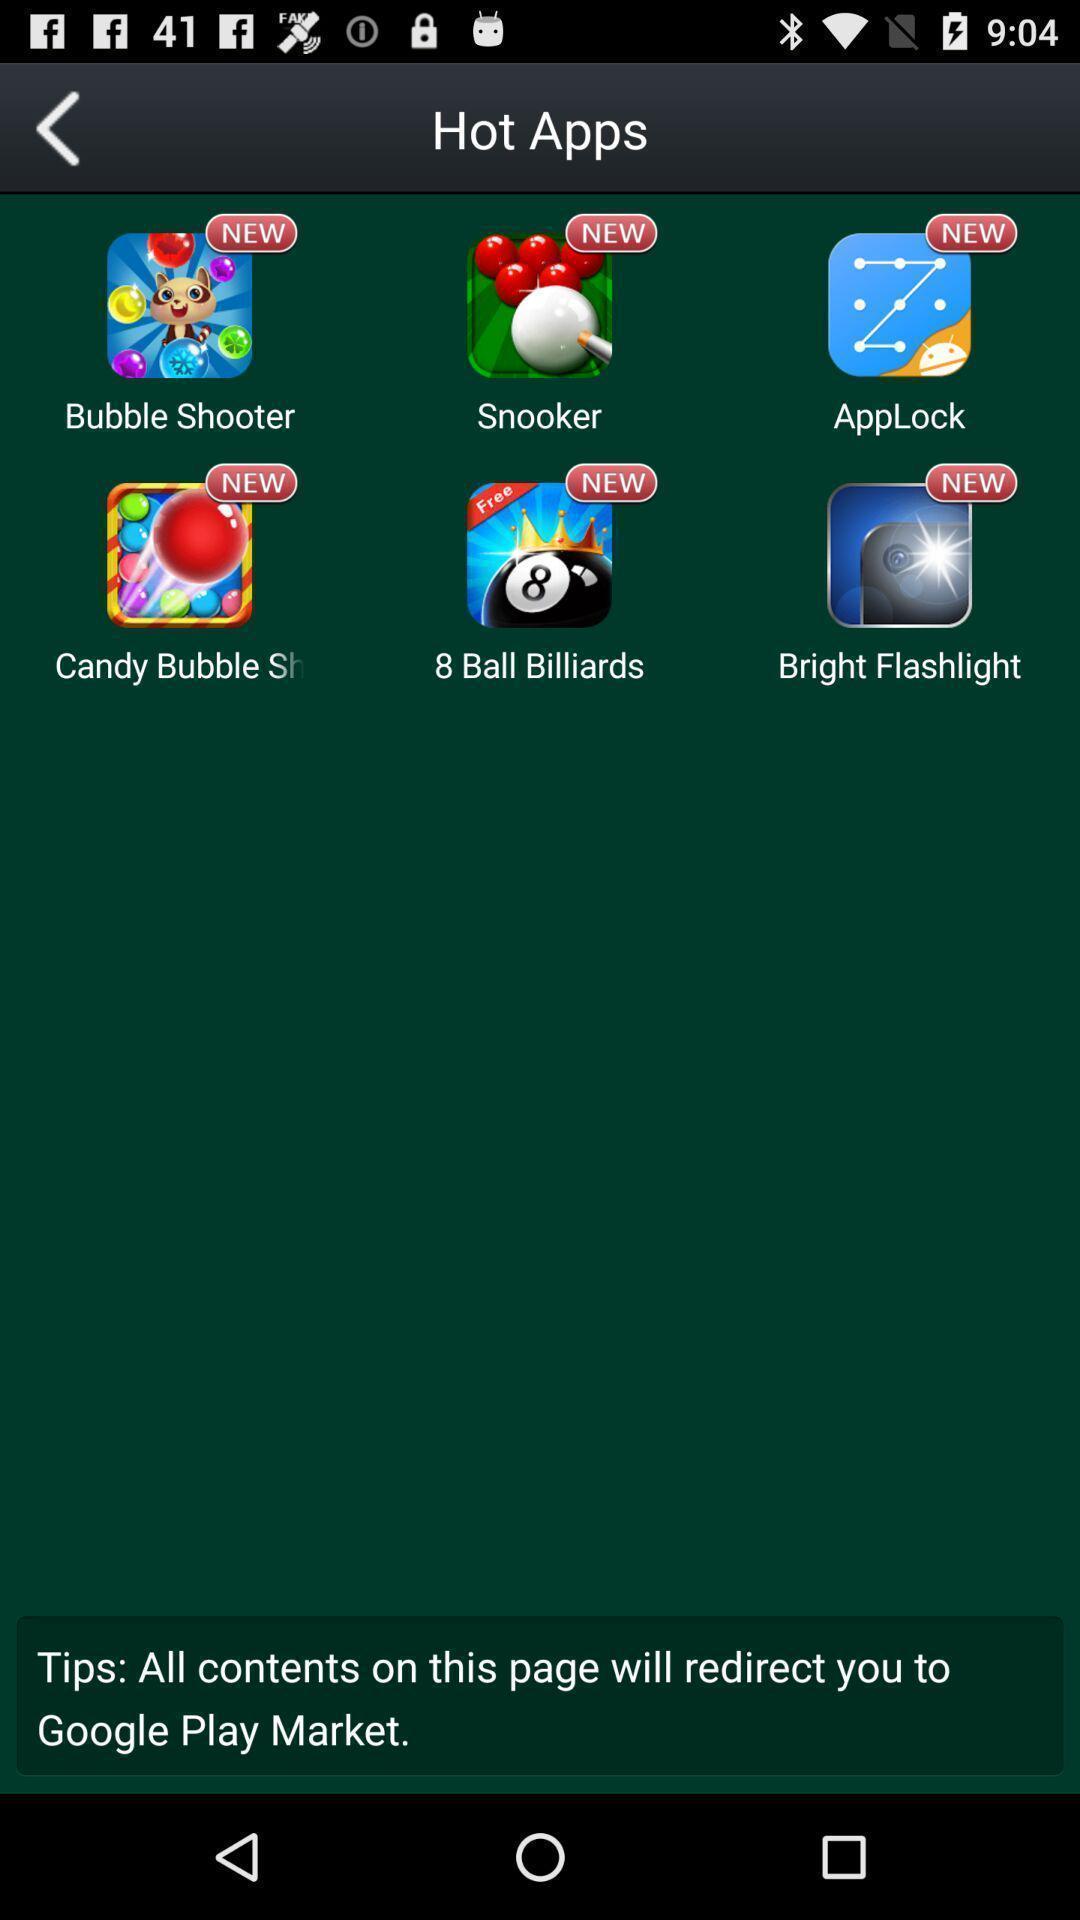Describe this image in words. Screen displaying multiple application icons with names. 